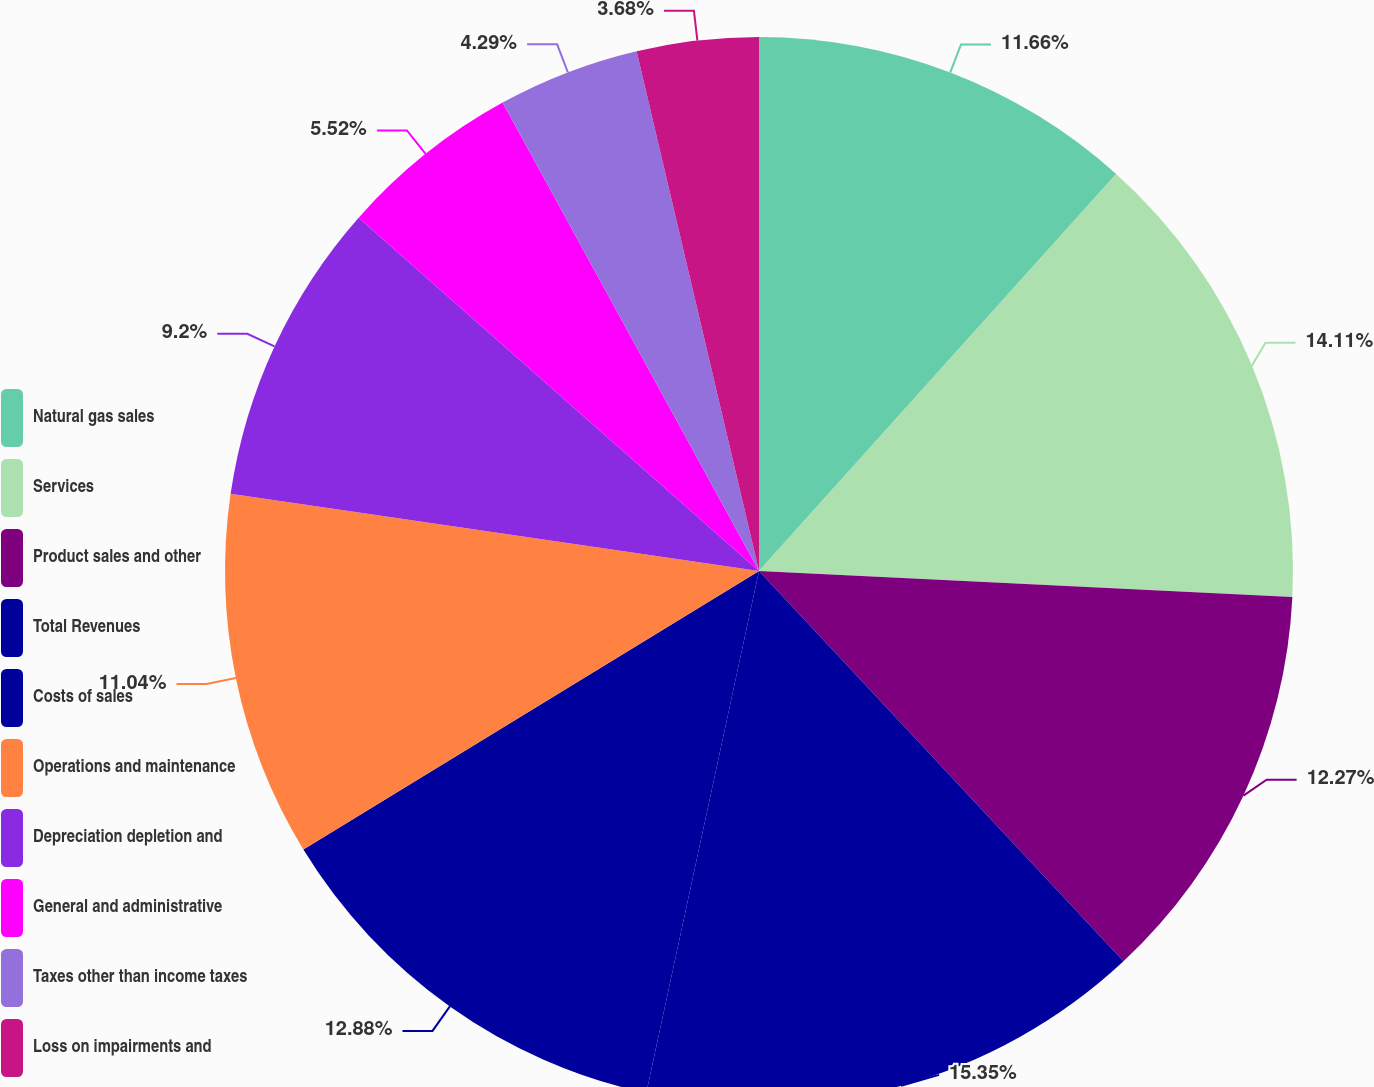Convert chart. <chart><loc_0><loc_0><loc_500><loc_500><pie_chart><fcel>Natural gas sales<fcel>Services<fcel>Product sales and other<fcel>Total Revenues<fcel>Costs of sales<fcel>Operations and maintenance<fcel>Depreciation depletion and<fcel>General and administrative<fcel>Taxes other than income taxes<fcel>Loss on impairments and<nl><fcel>11.66%<fcel>14.11%<fcel>12.27%<fcel>15.34%<fcel>12.88%<fcel>11.04%<fcel>9.2%<fcel>5.52%<fcel>4.29%<fcel>3.68%<nl></chart> 